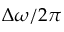Convert formula to latex. <formula><loc_0><loc_0><loc_500><loc_500>\Delta \omega / 2 \pi</formula> 